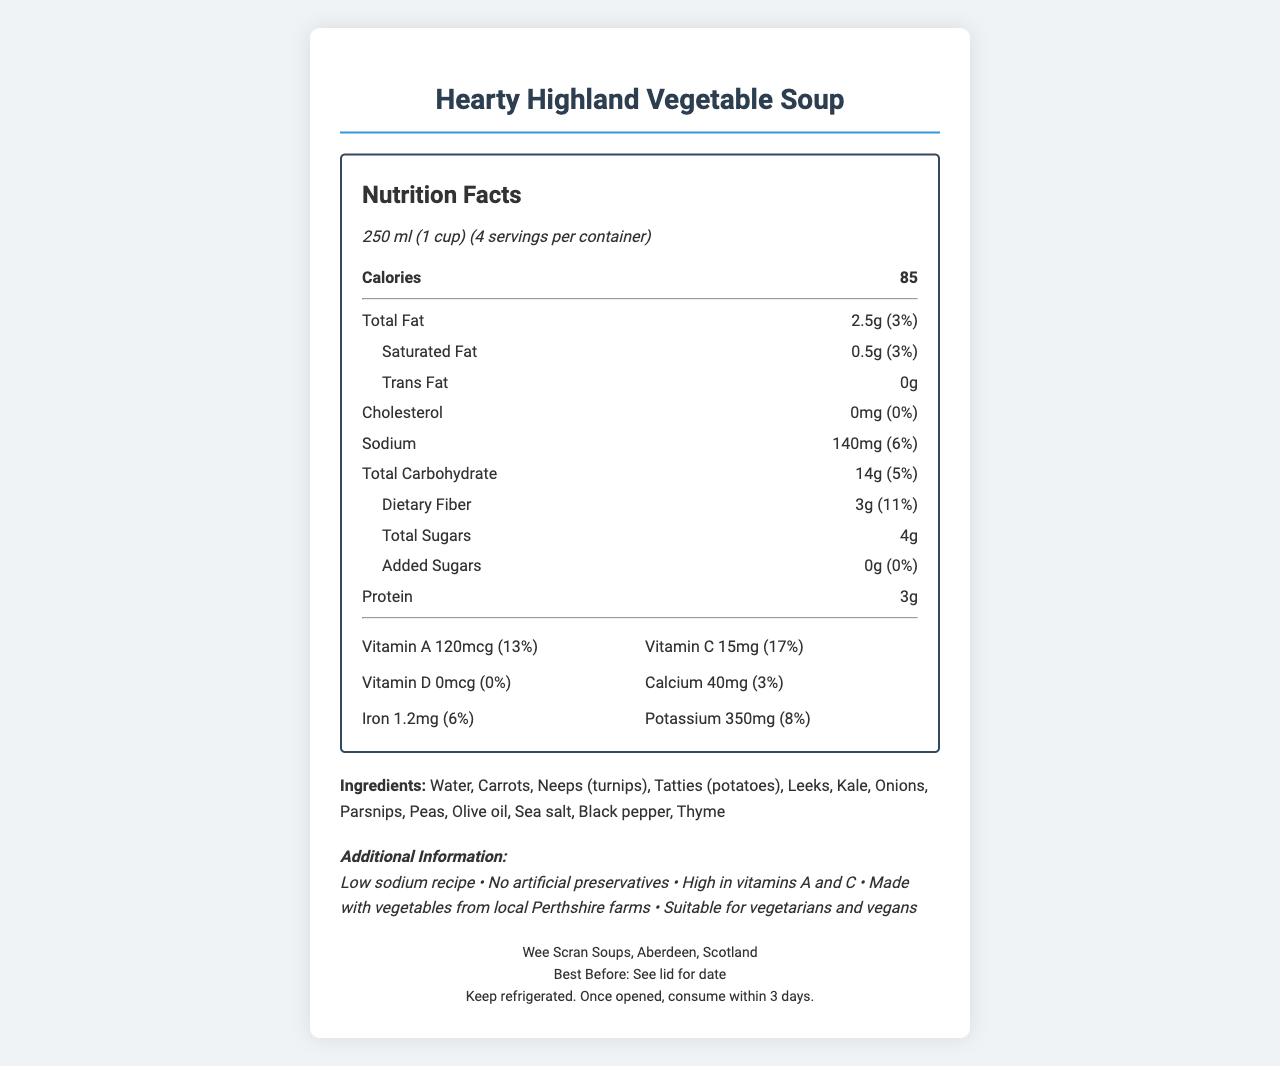what is the serving size? The serving size is explicitly stated near the top of the nutrition label.
Answer: 250 ml (1 cup) how many servings are there per container? The document mentions there are 4 servings per container.
Answer: 4 how many calories are in one serving of the Hearty Highland Vegetable Soup? The calorie content per serving is listed as 85.
Answer: 85 how much total fat is in a serving? The total fat per serving is provided as 2.5g.
Answer: 2.5g what percentage of the daily value of sodium does one serving contain? The sodium content per serving is 140mg, which is 6% of the daily value.
Answer: 6% which ingredient is listed first in the ingredients list? According to the ingredients list, water is the first ingredient.
Answer: Water how much dietary fiber is in each serving? Each serving contains 3g of dietary fiber.
Answer: 3g how much vitamin A does the soup provide per serving? The amount of vitamin A per serving is given as 120mcg.
Answer: 120mcg how much vitamin C does the soup contain? The soup contains 15mg of vitamin C per serving.
Answer: 15mg does this product contain any trans fat? The document specifies that the trans fat content is 0g.
Answer: No which of the following ingredients is present in the Hearty Highland Vegetable Soup? A. Broccoli B. Kale C. Zucchini Kale is listed in the soup's ingredients.
Answer: B. Kale which nutrient is not present at all in the soup? A. Vitamin C B. Cholesterol C. Potassium Cholesterol is listed as 0mg, meaning it's not present in the soup.
Answer: B. Cholesterol is the Hearty Highland Vegetable Soup suitable for vegans? The additional information confirms it is suitable for vegetarians and vegans.
Answer: Yes are there any artificial preservatives in the soup? The additional information states there are no artificial preservatives.
Answer: No what is the main idea or summary of this document? The summary covers the key points presented in the document, including nutritional details, ingredient list, and additional product features.
Answer: The document provides the nutrition facts, ingredients, and additional information about the Hearty Highland Vegetable Soup, highlighting its low sodium content, high vitamin A and C content, and suitability for vegetarians and vegans. where is "Wee Scran Soups" located? The manufacturer's location is provided as Aberdeen, Scotland.
Answer: Aberdeen, Scotland how long after opening should the soup be consumed? The storage instructions recommend consuming the soup within 3 days of opening.
Answer: Within 3 days how much potassium does one serving of this soup provide? The potassium content per serving is listed as 350mg.
Answer: 350mg how much added sugars are there in the soup? The added sugars content is listed as 0g.
Answer: 0g when was the soup produced? The document does not provide the production date, only the best before date, which requires checking the lid for specifics.
Answer: I don't know 